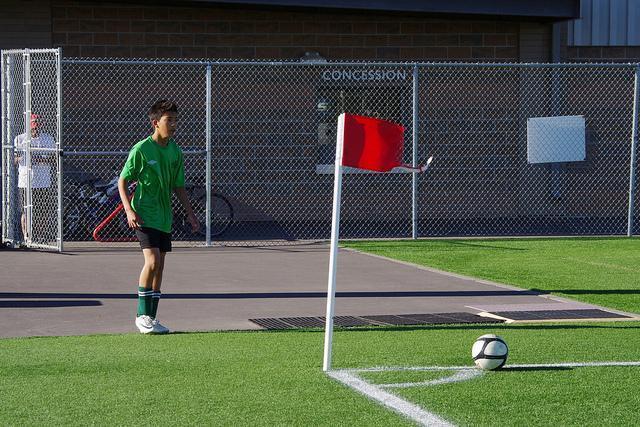How many pictures are shown?
Give a very brief answer. 1. How many bicycles are in the picture?
Give a very brief answer. 2. How many people can you see?
Give a very brief answer. 2. 